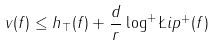<formula> <loc_0><loc_0><loc_500><loc_500>v ( f ) \leq h _ { \top } ( f ) + \frac { d } { r } \log ^ { + } \L i p ^ { + } ( f )</formula> 